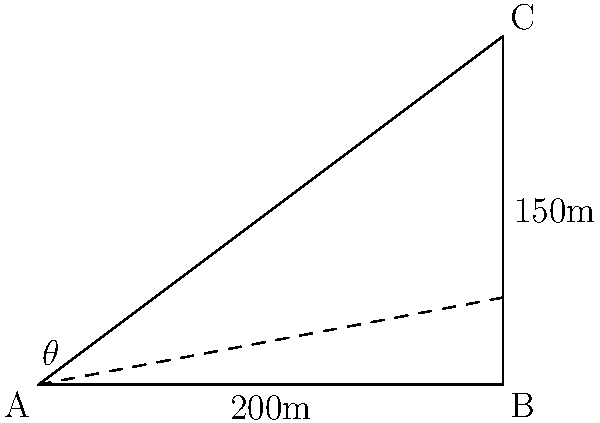As part of a leadership development program, you're organizing a team-building exercise that involves observing the city skyline from different perspectives. From a vantage point 200 meters away from the base of a skyscraper, team members need to calculate the angle of elevation to the top of the building, which is 150 meters tall. What is the angle of elevation (θ) to the nearest degree? To solve this problem, we'll use trigonometry, specifically the tangent function. Let's break it down step-by-step:

1) In this scenario, we have a right triangle where:
   - The adjacent side (distance from the observer to the base of the skyscraper) is 200 meters
   - The opposite side (height of the skyscraper) is 150 meters
   - We need to find the angle θ

2) The tangent of an angle in a right triangle is defined as the ratio of the opposite side to the adjacent side:

   $$\tan(\theta) = \frac{\text{opposite}}{\text{adjacent}}$$

3) Plugging in our values:

   $$\tan(\theta) = \frac{150}{200}$$

4) To find θ, we need to use the inverse tangent (arctan or tan^(-1)) function:

   $$\theta = \tan^{-1}(\frac{150}{200})$$

5) Using a calculator or computer:

   $$\theta \approx 36.87\text{ degrees}$$

6) Rounding to the nearest degree:

   $$\theta \approx 37\text{ degrees}$$

This exercise demonstrates how different perspectives (represented by the angle) can affect one's view of a situation, which is a valuable lesson in leadership and organizational behavior.
Answer: 37° 